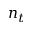Convert formula to latex. <formula><loc_0><loc_0><loc_500><loc_500>n _ { t }</formula> 